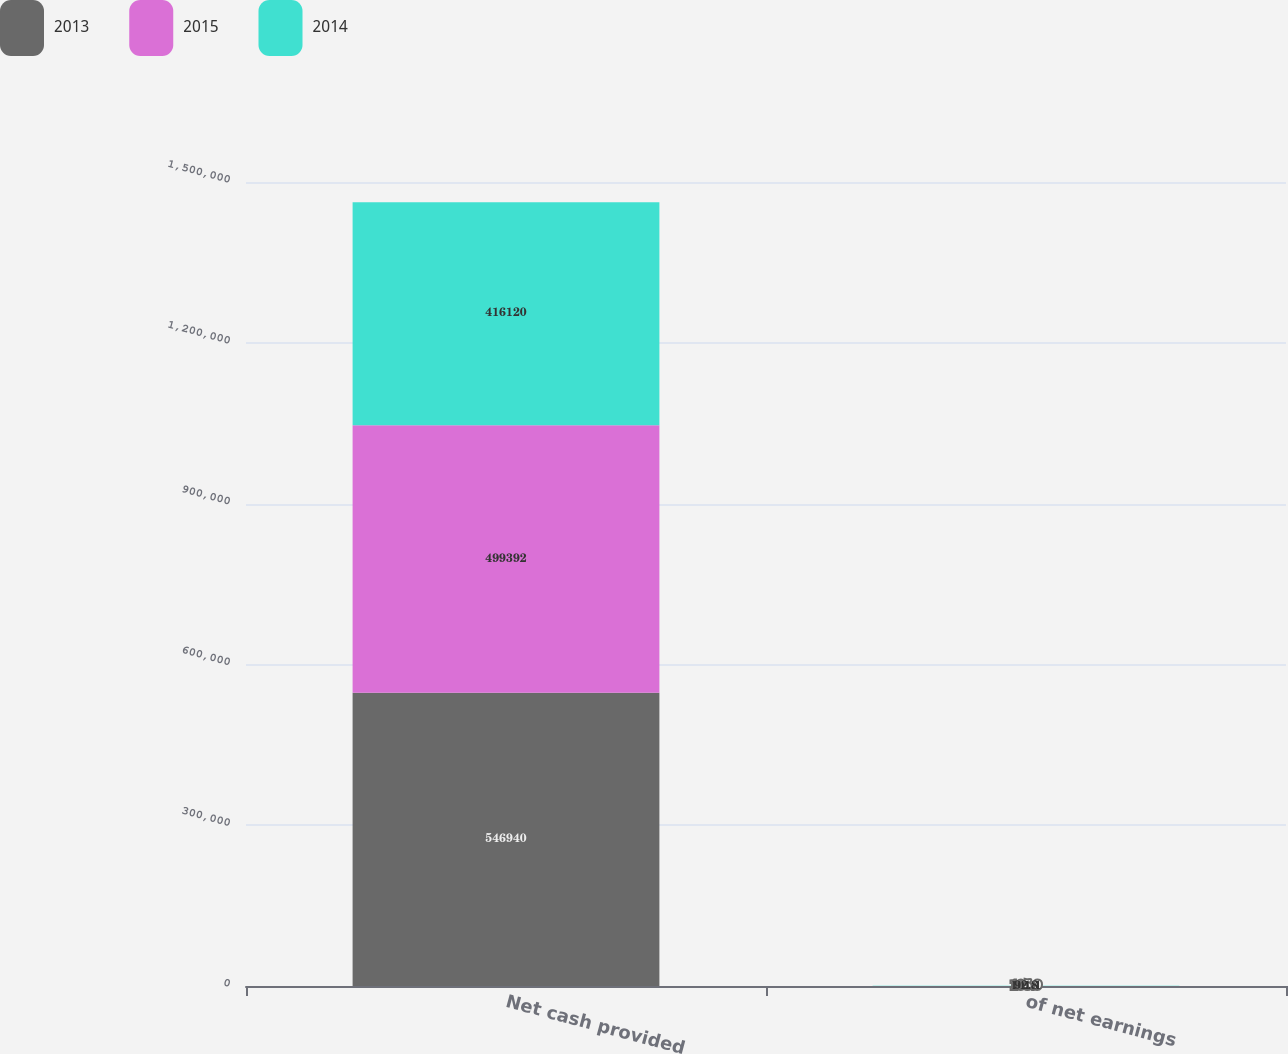Convert chart. <chart><loc_0><loc_0><loc_500><loc_500><stacked_bar_chart><ecel><fcel>Net cash provided<fcel>of net earnings<nl><fcel>2013<fcel>546940<fcel>105.9<nl><fcel>2015<fcel>499392<fcel>101.1<nl><fcel>2014<fcel>416120<fcel>92.8<nl></chart> 